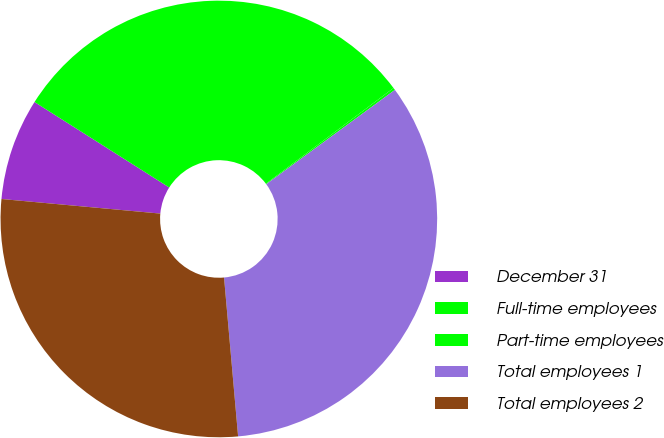Convert chart. <chart><loc_0><loc_0><loc_500><loc_500><pie_chart><fcel>December 31<fcel>Full-time employees<fcel>Part-time employees<fcel>Total employees 1<fcel>Total employees 2<nl><fcel>7.54%<fcel>30.76%<fcel>0.17%<fcel>33.66%<fcel>27.86%<nl></chart> 